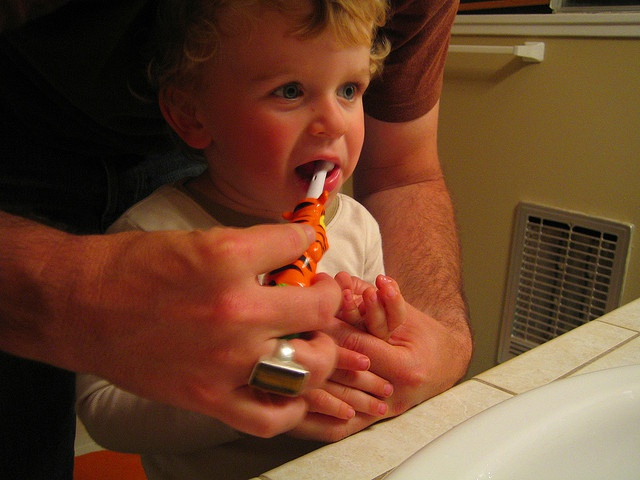Describe the objects in this image and their specific colors. I can see people in black, maroon, and brown tones, people in black, maroon, and brown tones, sink in black, beige, tan, and lightgray tones, and toothbrush in black, red, brown, and maroon tones in this image. 